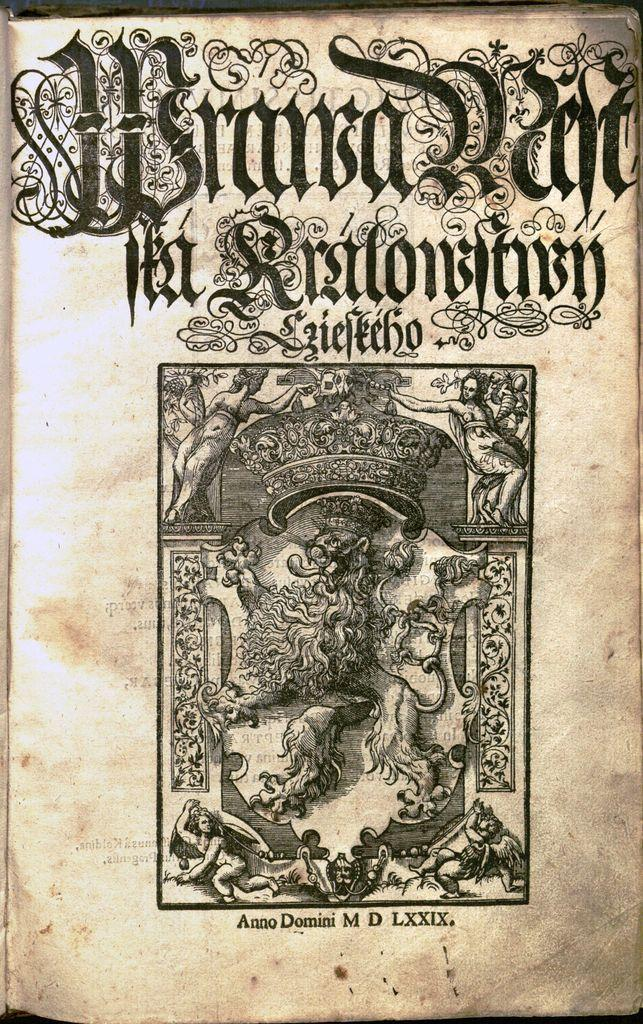<image>
Render a clear and concise summary of the photo. A worn book by Anno Domini M D LXXIX. 